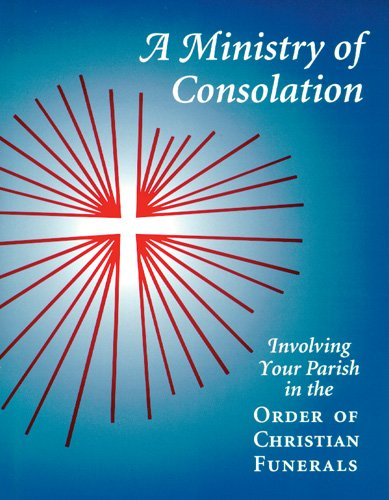What type of book is this? This book belongs to the 'Christian Books & Bibles' category, focusing on guiding parishes in ministering to families during funerals. 